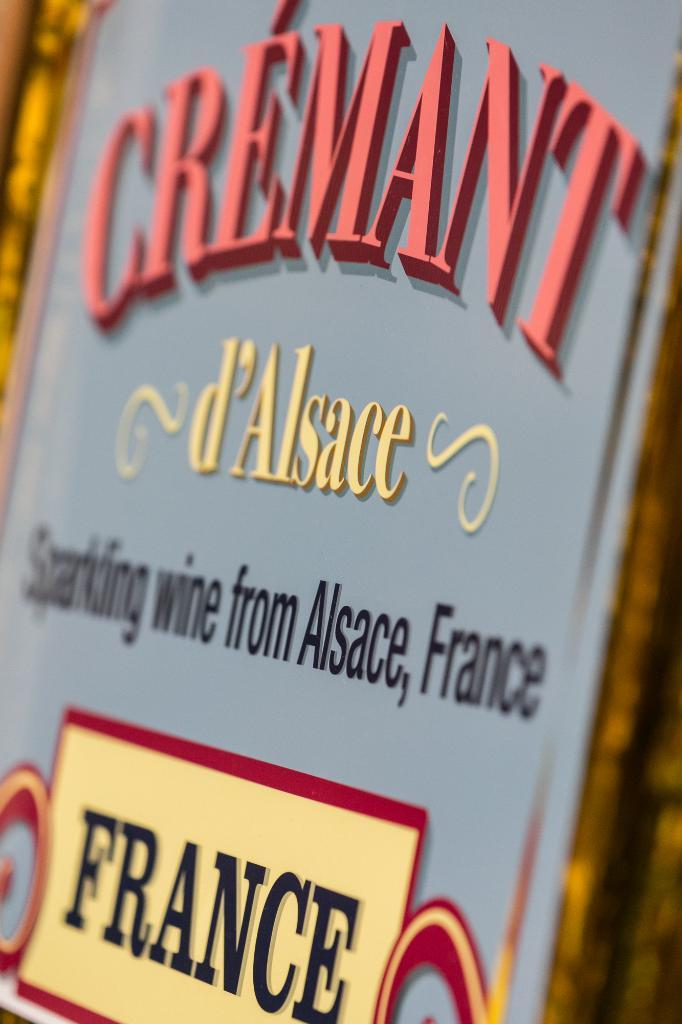<image>
Render a clear and concise summary of the photo. A decorative sign for sparkling wine from France. 